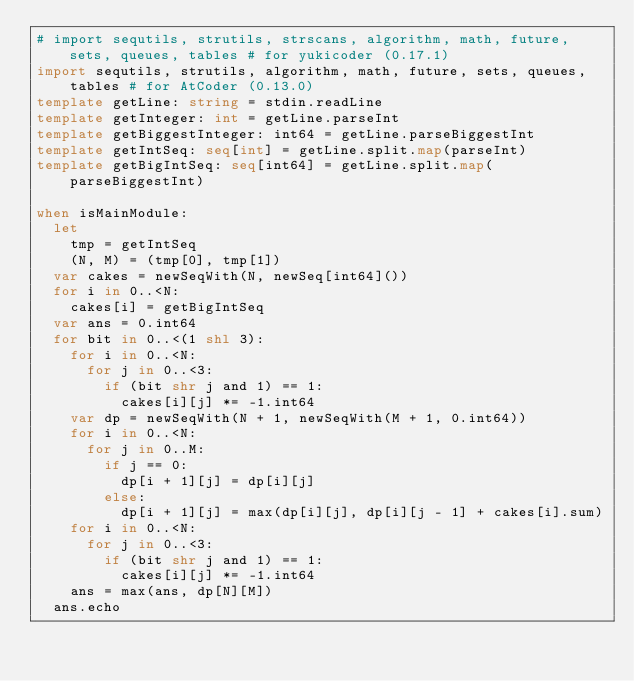<code> <loc_0><loc_0><loc_500><loc_500><_Nim_># import sequtils, strutils, strscans, algorithm, math, future, sets, queues, tables # for yukicoder (0.17.1)
import sequtils, strutils, algorithm, math, future, sets, queues, tables # for AtCoder (0.13.0)
template getLine: string = stdin.readLine
template getInteger: int = getLine.parseInt
template getBiggestInteger: int64 = getLine.parseBiggestInt
template getIntSeq: seq[int] = getLine.split.map(parseInt)
template getBigIntSeq: seq[int64] = getLine.split.map(parseBiggestInt)

when isMainModule:
  let
    tmp = getIntSeq
    (N, M) = (tmp[0], tmp[1])
  var cakes = newSeqWith(N, newSeq[int64]())
  for i in 0..<N:
    cakes[i] = getBigIntSeq
  var ans = 0.int64
  for bit in 0..<(1 shl 3):
    for i in 0..<N:
      for j in 0..<3:
        if (bit shr j and 1) == 1:
          cakes[i][j] *= -1.int64
    var dp = newSeqWith(N + 1, newSeqWith(M + 1, 0.int64))
    for i in 0..<N:
      for j in 0..M:
        if j == 0:
          dp[i + 1][j] = dp[i][j]
        else:
          dp[i + 1][j] = max(dp[i][j], dp[i][j - 1] + cakes[i].sum)
    for i in 0..<N:
      for j in 0..<3:
        if (bit shr j and 1) == 1:
          cakes[i][j] *= -1.int64
    ans = max(ans, dp[N][M])
  ans.echo
</code> 